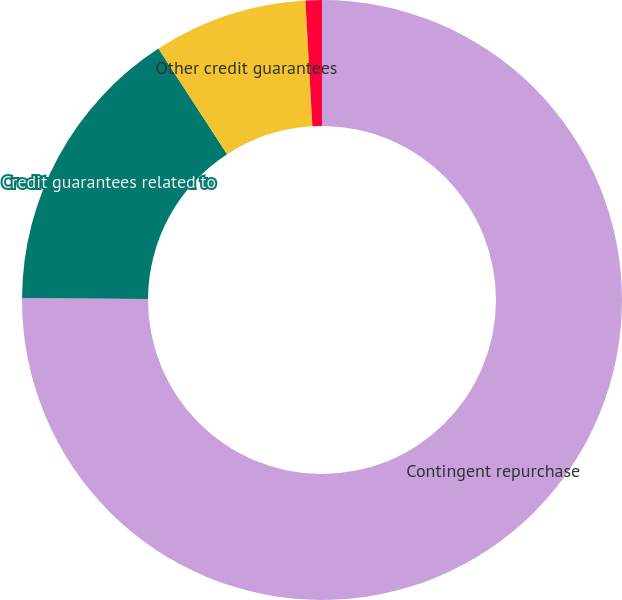<chart> <loc_0><loc_0><loc_500><loc_500><pie_chart><fcel>Contingent repurchase<fcel>Credit guarantees related to<fcel>Other credit guarantees<fcel>Residual value guarantees<nl><fcel>75.1%<fcel>15.72%<fcel>8.3%<fcel>0.88%<nl></chart> 